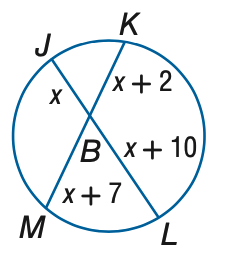Answer the mathemtical geometry problem and directly provide the correct option letter.
Question: Find x to the nearest tenth. Assume that segments that appear to be tangent are tangent.
Choices: A: 14 B: 16 C: 18 D: 20 A 